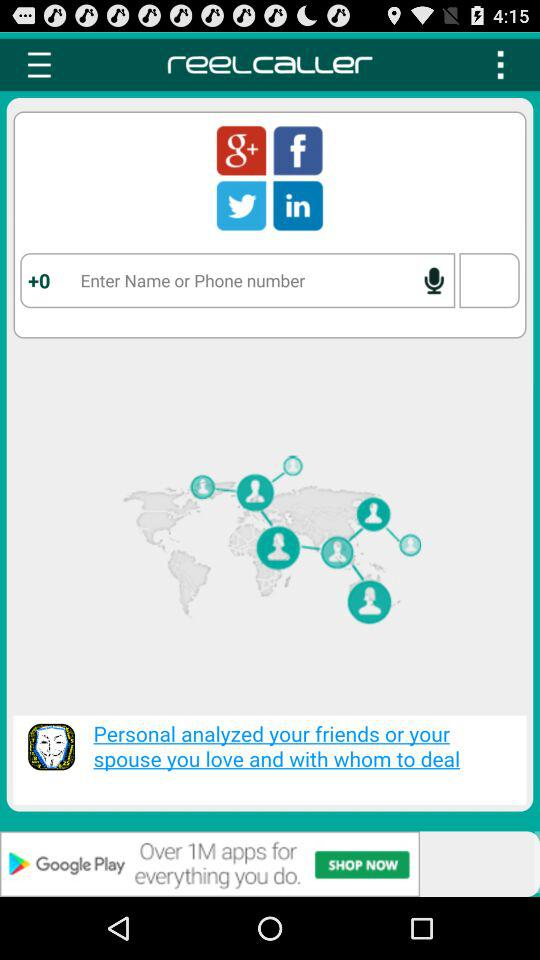What is the name of the application? The name of the application is "reelcaller". 